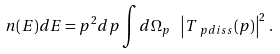<formula> <loc_0><loc_0><loc_500><loc_500>n ( E ) d E = p ^ { 2 } d p \int d \Omega _ { p } \ \left | T _ { \ p { d i s s } } ( p ) \right | ^ { 2 } \, .</formula> 